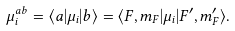Convert formula to latex. <formula><loc_0><loc_0><loc_500><loc_500>\mu _ { i } ^ { a b } = \langle a | \mu _ { i } | b \rangle = \langle F , m _ { F } | \mu _ { i } | F ^ { \prime } , m _ { F } ^ { \prime } \rangle .</formula> 